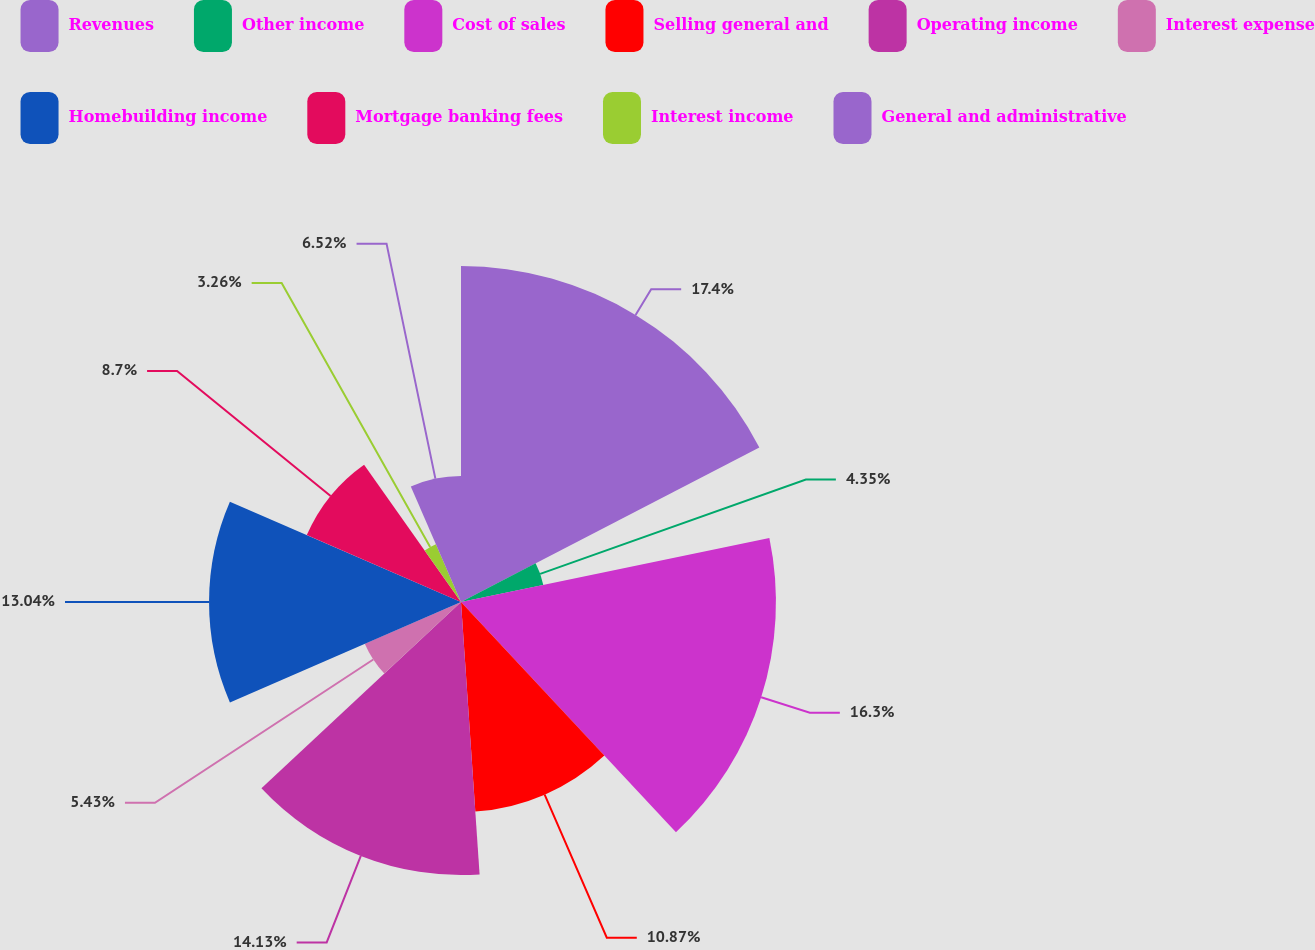Convert chart to OTSL. <chart><loc_0><loc_0><loc_500><loc_500><pie_chart><fcel>Revenues<fcel>Other income<fcel>Cost of sales<fcel>Selling general and<fcel>Operating income<fcel>Interest expense<fcel>Homebuilding income<fcel>Mortgage banking fees<fcel>Interest income<fcel>General and administrative<nl><fcel>17.39%<fcel>4.35%<fcel>16.3%<fcel>10.87%<fcel>14.13%<fcel>5.43%<fcel>13.04%<fcel>8.7%<fcel>3.26%<fcel>6.52%<nl></chart> 